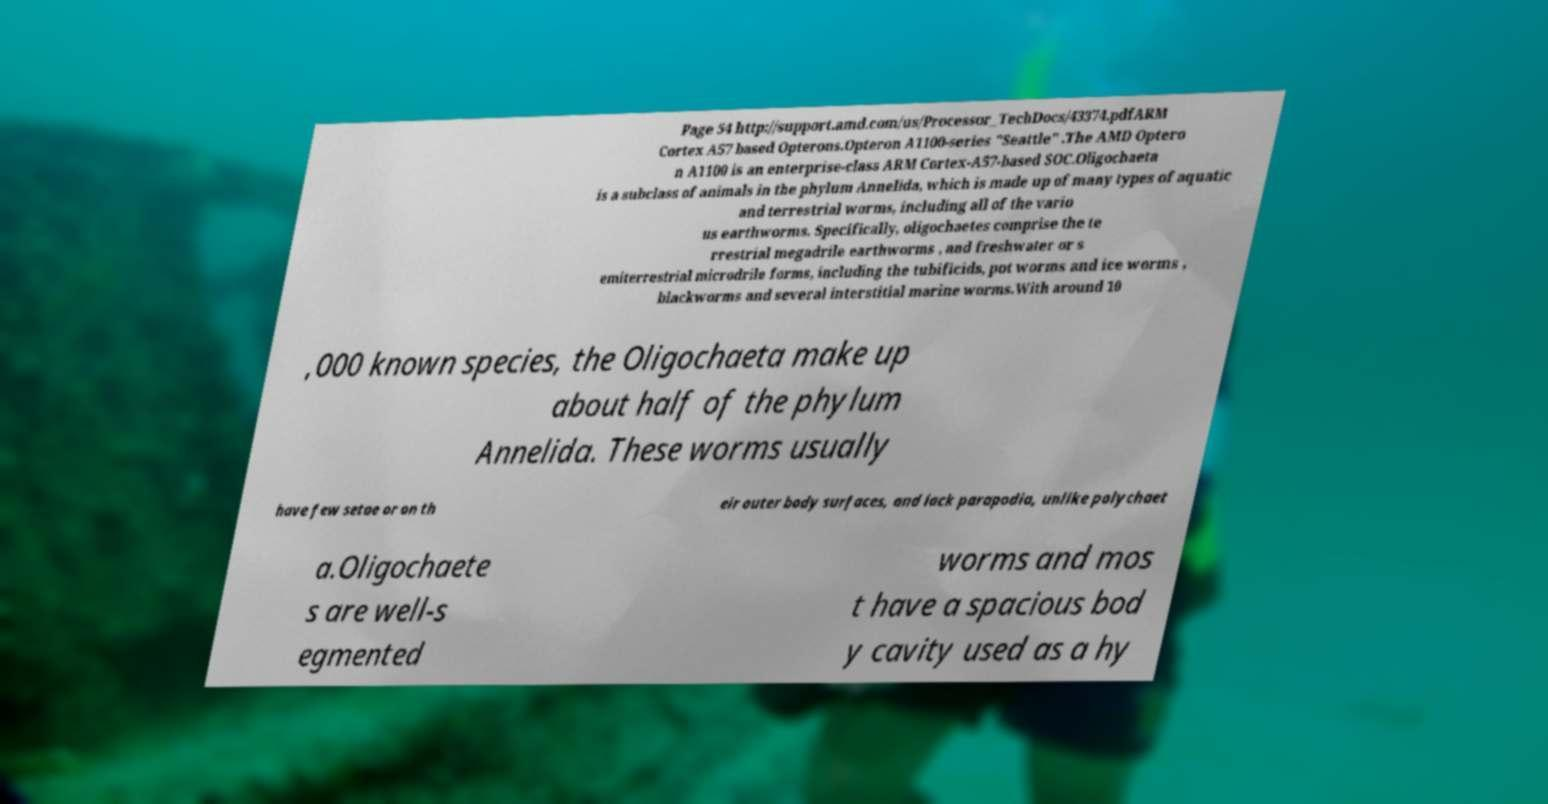Please identify and transcribe the text found in this image. Page 54 http://support.amd.com/us/Processor_TechDocs/43374.pdfARM Cortex A57 based Opterons.Opteron A1100-series "Seattle" .The AMD Optero n A1100 is an enterprise-class ARM Cortex-A57-based SOC.Oligochaeta is a subclass of animals in the phylum Annelida, which is made up of many types of aquatic and terrestrial worms, including all of the vario us earthworms. Specifically, oligochaetes comprise the te rrestrial megadrile earthworms , and freshwater or s emiterrestrial microdrile forms, including the tubificids, pot worms and ice worms , blackworms and several interstitial marine worms.With around 10 ,000 known species, the Oligochaeta make up about half of the phylum Annelida. These worms usually have few setae or on th eir outer body surfaces, and lack parapodia, unlike polychaet a.Oligochaete s are well-s egmented worms and mos t have a spacious bod y cavity used as a hy 